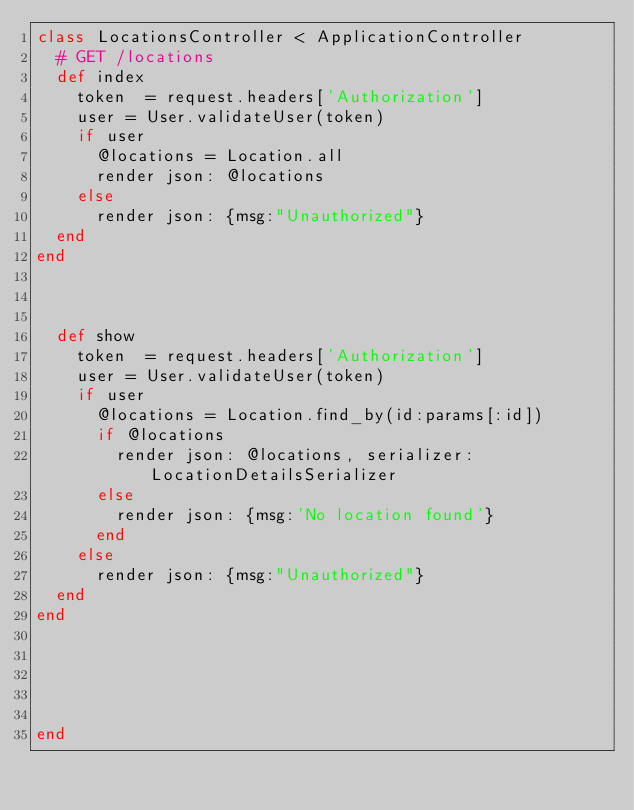Convert code to text. <code><loc_0><loc_0><loc_500><loc_500><_Ruby_>class LocationsController < ApplicationController
  # GET /locations
  def index
    token  = request.headers['Authorization']
    user = User.validateUser(token)
    if user
      @locations = Location.all
      render json: @locations
    else
      render json: {msg:"Unauthorized"}
  end
end



  def show
    token  = request.headers['Authorization']
    user = User.validateUser(token)
    if user
      @locations = Location.find_by(id:params[:id])
      if @locations
        render json: @locations, serializer:LocationDetailsSerializer
      else
        render json: {msg:'No location found'}
      end
    else
      render json: {msg:"Unauthorized"}
  end
end


  

  
end
</code> 